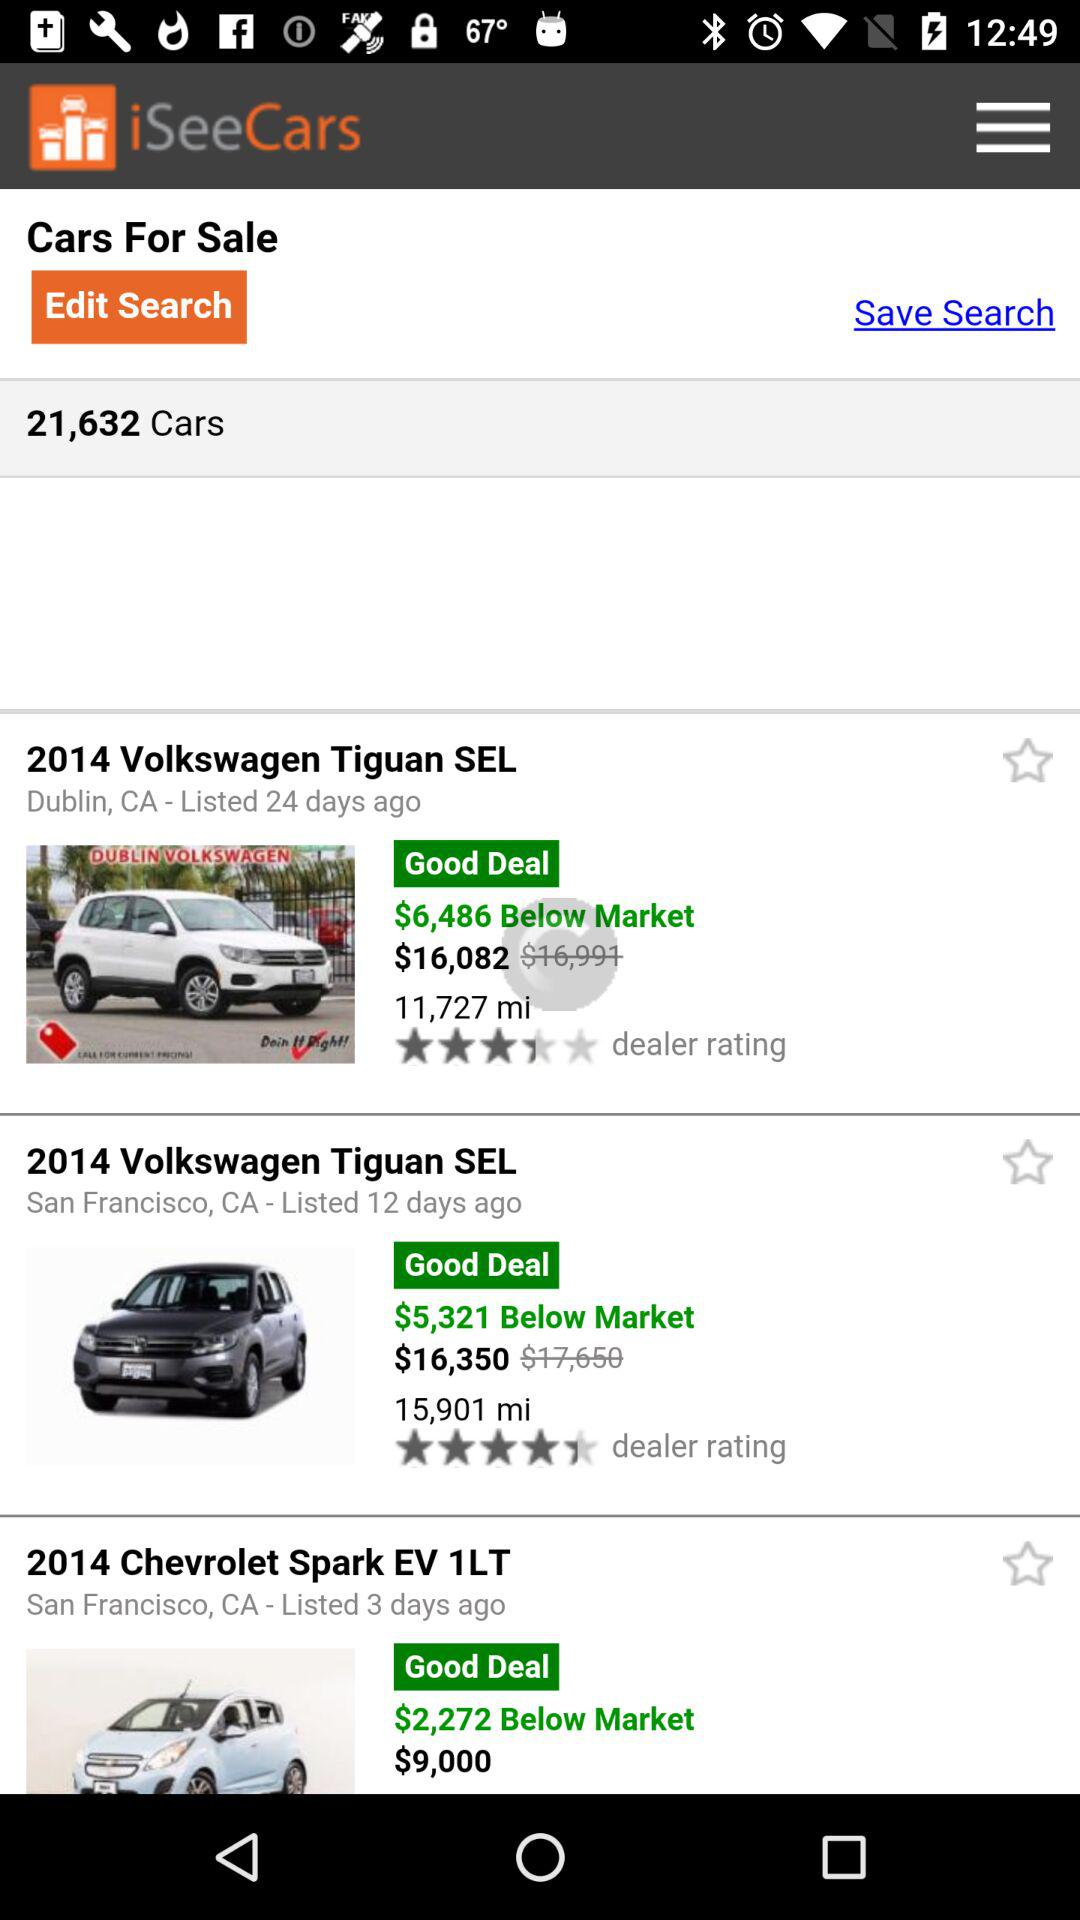Which car is the most expensive?
When the provided information is insufficient, respond with <no answer>. <no answer> 